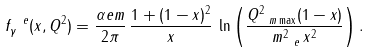<formula> <loc_0><loc_0><loc_500><loc_500>f _ { \gamma } ^ { \ e } ( x , Q ^ { 2 } ) = \frac { \alpha e m } { 2 \pi } \, \frac { 1 + ( 1 - x ) ^ { 2 } } { x } \, \ln \left ( \frac { Q ^ { 2 } _ { \ m \max } ( 1 - x ) } { m _ { \ e } ^ { 2 } \, x ^ { 2 } } \right ) .</formula> 